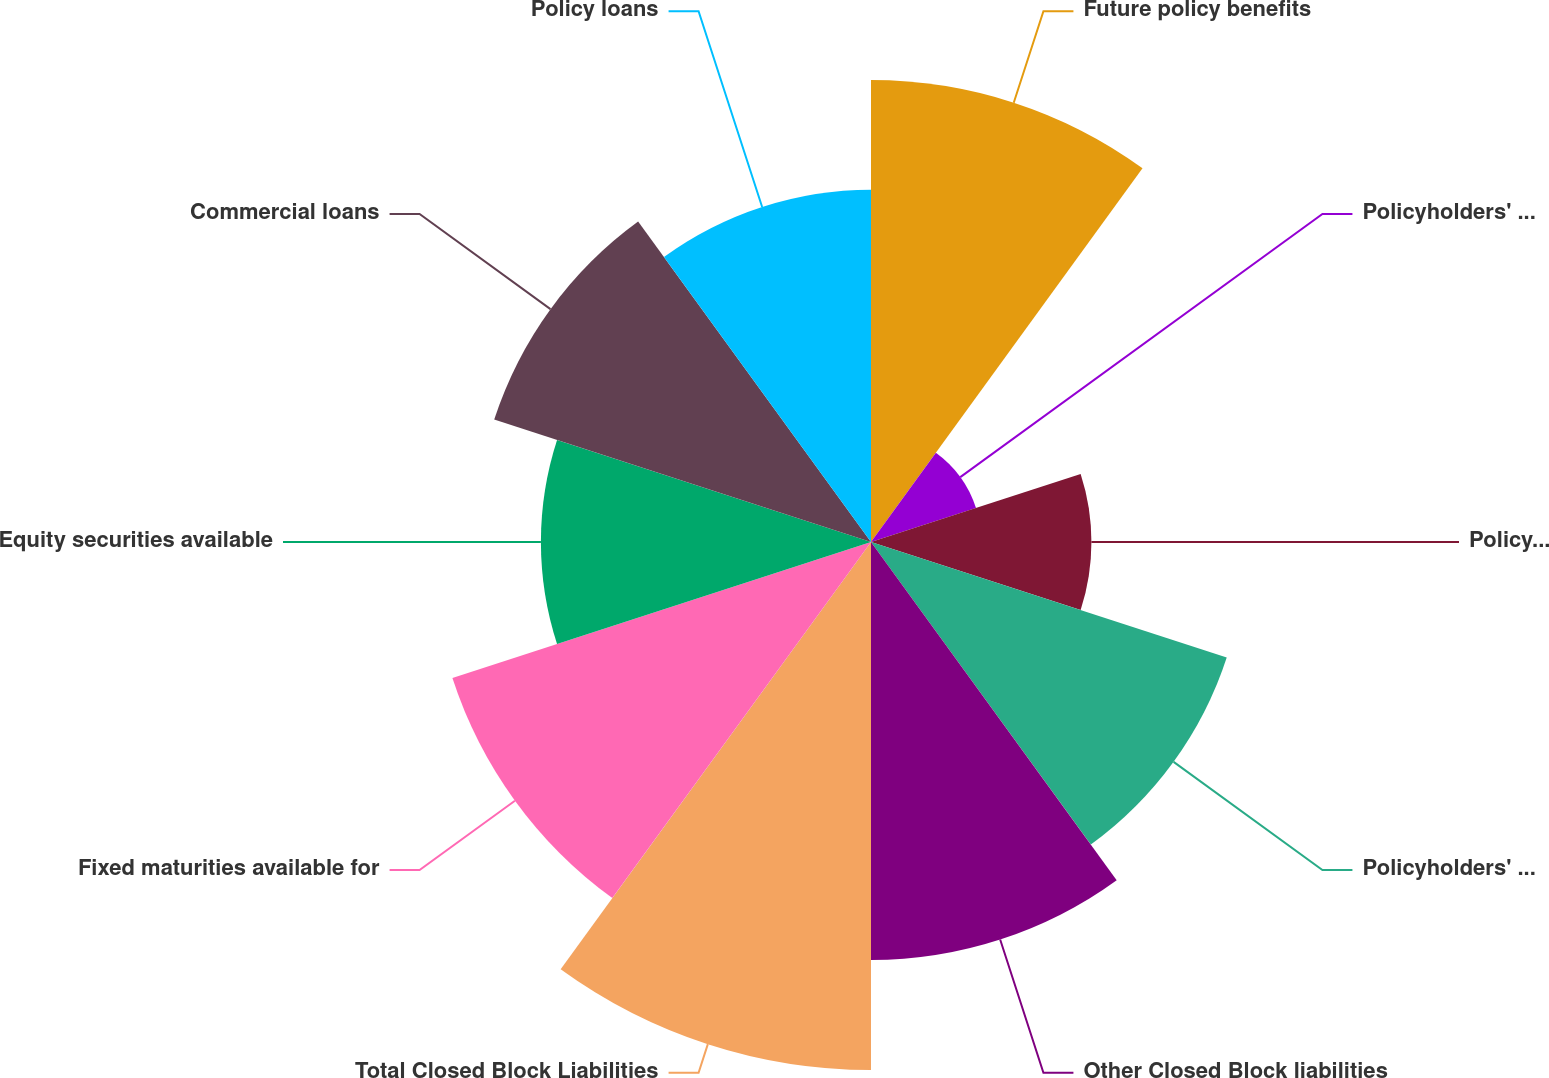Convert chart to OTSL. <chart><loc_0><loc_0><loc_500><loc_500><pie_chart><fcel>Future policy benefits<fcel>Policyholders' dividends<fcel>Policyholder dividend<fcel>Policyholders' account<fcel>Other Closed Block liabilities<fcel>Total Closed Block Liabilities<fcel>Fixed maturities available for<fcel>Equity securities available<fcel>Commercial loans<fcel>Policy loans<nl><fcel>12.72%<fcel>3.04%<fcel>6.07%<fcel>10.3%<fcel>11.51%<fcel>14.54%<fcel>12.12%<fcel>9.09%<fcel>10.91%<fcel>9.7%<nl></chart> 